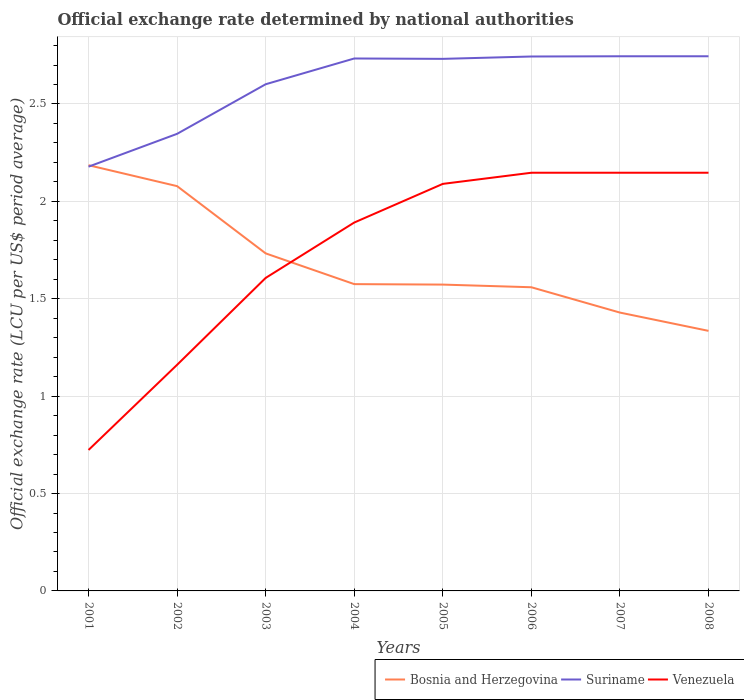Is the number of lines equal to the number of legend labels?
Ensure brevity in your answer.  Yes. Across all years, what is the maximum official exchange rate in Suriname?
Provide a short and direct response. 2.18. In which year was the official exchange rate in Venezuela maximum?
Offer a very short reply. 2001. What is the total official exchange rate in Venezuela in the graph?
Provide a short and direct response. -0.54. What is the difference between the highest and the second highest official exchange rate in Suriname?
Keep it short and to the point. 0.57. What is the difference between the highest and the lowest official exchange rate in Suriname?
Make the answer very short. 5. Is the official exchange rate in Suriname strictly greater than the official exchange rate in Bosnia and Herzegovina over the years?
Your answer should be very brief. No. Are the values on the major ticks of Y-axis written in scientific E-notation?
Ensure brevity in your answer.  No. Does the graph contain any zero values?
Offer a very short reply. No. Where does the legend appear in the graph?
Offer a very short reply. Bottom right. How many legend labels are there?
Give a very brief answer. 3. What is the title of the graph?
Give a very brief answer. Official exchange rate determined by national authorities. Does "Australia" appear as one of the legend labels in the graph?
Your answer should be compact. No. What is the label or title of the X-axis?
Your response must be concise. Years. What is the label or title of the Y-axis?
Keep it short and to the point. Official exchange rate (LCU per US$ period average). What is the Official exchange rate (LCU per US$ period average) in Bosnia and Herzegovina in 2001?
Provide a short and direct response. 2.19. What is the Official exchange rate (LCU per US$ period average) of Suriname in 2001?
Make the answer very short. 2.18. What is the Official exchange rate (LCU per US$ period average) in Venezuela in 2001?
Ensure brevity in your answer.  0.72. What is the Official exchange rate (LCU per US$ period average) of Bosnia and Herzegovina in 2002?
Give a very brief answer. 2.08. What is the Official exchange rate (LCU per US$ period average) of Suriname in 2002?
Your response must be concise. 2.35. What is the Official exchange rate (LCU per US$ period average) of Venezuela in 2002?
Give a very brief answer. 1.16. What is the Official exchange rate (LCU per US$ period average) of Bosnia and Herzegovina in 2003?
Provide a short and direct response. 1.73. What is the Official exchange rate (LCU per US$ period average) of Suriname in 2003?
Provide a succinct answer. 2.6. What is the Official exchange rate (LCU per US$ period average) of Venezuela in 2003?
Your answer should be very brief. 1.61. What is the Official exchange rate (LCU per US$ period average) of Bosnia and Herzegovina in 2004?
Your answer should be very brief. 1.58. What is the Official exchange rate (LCU per US$ period average) of Suriname in 2004?
Ensure brevity in your answer.  2.73. What is the Official exchange rate (LCU per US$ period average) in Venezuela in 2004?
Offer a terse response. 1.89. What is the Official exchange rate (LCU per US$ period average) in Bosnia and Herzegovina in 2005?
Make the answer very short. 1.57. What is the Official exchange rate (LCU per US$ period average) in Suriname in 2005?
Give a very brief answer. 2.73. What is the Official exchange rate (LCU per US$ period average) in Venezuela in 2005?
Make the answer very short. 2.09. What is the Official exchange rate (LCU per US$ period average) in Bosnia and Herzegovina in 2006?
Make the answer very short. 1.56. What is the Official exchange rate (LCU per US$ period average) of Suriname in 2006?
Keep it short and to the point. 2.74. What is the Official exchange rate (LCU per US$ period average) in Venezuela in 2006?
Give a very brief answer. 2.15. What is the Official exchange rate (LCU per US$ period average) in Bosnia and Herzegovina in 2007?
Offer a terse response. 1.43. What is the Official exchange rate (LCU per US$ period average) in Suriname in 2007?
Ensure brevity in your answer.  2.75. What is the Official exchange rate (LCU per US$ period average) of Venezuela in 2007?
Provide a short and direct response. 2.15. What is the Official exchange rate (LCU per US$ period average) of Bosnia and Herzegovina in 2008?
Provide a short and direct response. 1.34. What is the Official exchange rate (LCU per US$ period average) in Suriname in 2008?
Ensure brevity in your answer.  2.75. What is the Official exchange rate (LCU per US$ period average) in Venezuela in 2008?
Offer a very short reply. 2.15. Across all years, what is the maximum Official exchange rate (LCU per US$ period average) of Bosnia and Herzegovina?
Offer a very short reply. 2.19. Across all years, what is the maximum Official exchange rate (LCU per US$ period average) in Suriname?
Give a very brief answer. 2.75. Across all years, what is the maximum Official exchange rate (LCU per US$ period average) in Venezuela?
Offer a very short reply. 2.15. Across all years, what is the minimum Official exchange rate (LCU per US$ period average) of Bosnia and Herzegovina?
Your answer should be compact. 1.34. Across all years, what is the minimum Official exchange rate (LCU per US$ period average) of Suriname?
Provide a succinct answer. 2.18. Across all years, what is the minimum Official exchange rate (LCU per US$ period average) in Venezuela?
Give a very brief answer. 0.72. What is the total Official exchange rate (LCU per US$ period average) in Bosnia and Herzegovina in the graph?
Your response must be concise. 13.47. What is the total Official exchange rate (LCU per US$ period average) of Suriname in the graph?
Ensure brevity in your answer.  20.83. What is the total Official exchange rate (LCU per US$ period average) of Venezuela in the graph?
Make the answer very short. 13.91. What is the difference between the Official exchange rate (LCU per US$ period average) in Bosnia and Herzegovina in 2001 and that in 2002?
Offer a very short reply. 0.11. What is the difference between the Official exchange rate (LCU per US$ period average) in Suriname in 2001 and that in 2002?
Give a very brief answer. -0.17. What is the difference between the Official exchange rate (LCU per US$ period average) of Venezuela in 2001 and that in 2002?
Offer a terse response. -0.44. What is the difference between the Official exchange rate (LCU per US$ period average) of Bosnia and Herzegovina in 2001 and that in 2003?
Your answer should be compact. 0.45. What is the difference between the Official exchange rate (LCU per US$ period average) in Suriname in 2001 and that in 2003?
Give a very brief answer. -0.42. What is the difference between the Official exchange rate (LCU per US$ period average) of Venezuela in 2001 and that in 2003?
Offer a very short reply. -0.88. What is the difference between the Official exchange rate (LCU per US$ period average) of Bosnia and Herzegovina in 2001 and that in 2004?
Your answer should be very brief. 0.61. What is the difference between the Official exchange rate (LCU per US$ period average) of Suriname in 2001 and that in 2004?
Offer a very short reply. -0.56. What is the difference between the Official exchange rate (LCU per US$ period average) of Venezuela in 2001 and that in 2004?
Keep it short and to the point. -1.17. What is the difference between the Official exchange rate (LCU per US$ period average) of Bosnia and Herzegovina in 2001 and that in 2005?
Give a very brief answer. 0.61. What is the difference between the Official exchange rate (LCU per US$ period average) of Suriname in 2001 and that in 2005?
Give a very brief answer. -0.55. What is the difference between the Official exchange rate (LCU per US$ period average) of Venezuela in 2001 and that in 2005?
Keep it short and to the point. -1.37. What is the difference between the Official exchange rate (LCU per US$ period average) of Bosnia and Herzegovina in 2001 and that in 2006?
Give a very brief answer. 0.63. What is the difference between the Official exchange rate (LCU per US$ period average) of Suriname in 2001 and that in 2006?
Keep it short and to the point. -0.57. What is the difference between the Official exchange rate (LCU per US$ period average) in Venezuela in 2001 and that in 2006?
Provide a short and direct response. -1.42. What is the difference between the Official exchange rate (LCU per US$ period average) in Bosnia and Herzegovina in 2001 and that in 2007?
Make the answer very short. 0.76. What is the difference between the Official exchange rate (LCU per US$ period average) in Suriname in 2001 and that in 2007?
Give a very brief answer. -0.57. What is the difference between the Official exchange rate (LCU per US$ period average) of Venezuela in 2001 and that in 2007?
Offer a very short reply. -1.42. What is the difference between the Official exchange rate (LCU per US$ period average) in Bosnia and Herzegovina in 2001 and that in 2008?
Provide a succinct answer. 0.85. What is the difference between the Official exchange rate (LCU per US$ period average) of Suriname in 2001 and that in 2008?
Offer a terse response. -0.57. What is the difference between the Official exchange rate (LCU per US$ period average) of Venezuela in 2001 and that in 2008?
Your response must be concise. -1.42. What is the difference between the Official exchange rate (LCU per US$ period average) of Bosnia and Herzegovina in 2002 and that in 2003?
Your response must be concise. 0.35. What is the difference between the Official exchange rate (LCU per US$ period average) of Suriname in 2002 and that in 2003?
Your answer should be compact. -0.25. What is the difference between the Official exchange rate (LCU per US$ period average) in Venezuela in 2002 and that in 2003?
Keep it short and to the point. -0.45. What is the difference between the Official exchange rate (LCU per US$ period average) of Bosnia and Herzegovina in 2002 and that in 2004?
Provide a short and direct response. 0.5. What is the difference between the Official exchange rate (LCU per US$ period average) in Suriname in 2002 and that in 2004?
Provide a short and direct response. -0.39. What is the difference between the Official exchange rate (LCU per US$ period average) in Venezuela in 2002 and that in 2004?
Your response must be concise. -0.73. What is the difference between the Official exchange rate (LCU per US$ period average) of Bosnia and Herzegovina in 2002 and that in 2005?
Keep it short and to the point. 0.51. What is the difference between the Official exchange rate (LCU per US$ period average) of Suriname in 2002 and that in 2005?
Your response must be concise. -0.38. What is the difference between the Official exchange rate (LCU per US$ period average) of Venezuela in 2002 and that in 2005?
Offer a terse response. -0.93. What is the difference between the Official exchange rate (LCU per US$ period average) in Bosnia and Herzegovina in 2002 and that in 2006?
Your answer should be compact. 0.52. What is the difference between the Official exchange rate (LCU per US$ period average) of Suriname in 2002 and that in 2006?
Provide a succinct answer. -0.4. What is the difference between the Official exchange rate (LCU per US$ period average) of Venezuela in 2002 and that in 2006?
Give a very brief answer. -0.99. What is the difference between the Official exchange rate (LCU per US$ period average) of Bosnia and Herzegovina in 2002 and that in 2007?
Give a very brief answer. 0.65. What is the difference between the Official exchange rate (LCU per US$ period average) of Suriname in 2002 and that in 2007?
Your answer should be compact. -0.4. What is the difference between the Official exchange rate (LCU per US$ period average) in Venezuela in 2002 and that in 2007?
Your answer should be compact. -0.99. What is the difference between the Official exchange rate (LCU per US$ period average) in Bosnia and Herzegovina in 2002 and that in 2008?
Your response must be concise. 0.74. What is the difference between the Official exchange rate (LCU per US$ period average) in Suriname in 2002 and that in 2008?
Offer a terse response. -0.4. What is the difference between the Official exchange rate (LCU per US$ period average) in Venezuela in 2002 and that in 2008?
Provide a short and direct response. -0.99. What is the difference between the Official exchange rate (LCU per US$ period average) of Bosnia and Herzegovina in 2003 and that in 2004?
Make the answer very short. 0.16. What is the difference between the Official exchange rate (LCU per US$ period average) of Suriname in 2003 and that in 2004?
Provide a succinct answer. -0.13. What is the difference between the Official exchange rate (LCU per US$ period average) in Venezuela in 2003 and that in 2004?
Your answer should be very brief. -0.28. What is the difference between the Official exchange rate (LCU per US$ period average) in Bosnia and Herzegovina in 2003 and that in 2005?
Offer a very short reply. 0.16. What is the difference between the Official exchange rate (LCU per US$ period average) of Suriname in 2003 and that in 2005?
Your response must be concise. -0.13. What is the difference between the Official exchange rate (LCU per US$ period average) of Venezuela in 2003 and that in 2005?
Offer a terse response. -0.48. What is the difference between the Official exchange rate (LCU per US$ period average) of Bosnia and Herzegovina in 2003 and that in 2006?
Ensure brevity in your answer.  0.17. What is the difference between the Official exchange rate (LCU per US$ period average) of Suriname in 2003 and that in 2006?
Make the answer very short. -0.14. What is the difference between the Official exchange rate (LCU per US$ period average) in Venezuela in 2003 and that in 2006?
Offer a very short reply. -0.54. What is the difference between the Official exchange rate (LCU per US$ period average) of Bosnia and Herzegovina in 2003 and that in 2007?
Your response must be concise. 0.3. What is the difference between the Official exchange rate (LCU per US$ period average) of Suriname in 2003 and that in 2007?
Your response must be concise. -0.14. What is the difference between the Official exchange rate (LCU per US$ period average) of Venezuela in 2003 and that in 2007?
Provide a short and direct response. -0.54. What is the difference between the Official exchange rate (LCU per US$ period average) of Bosnia and Herzegovina in 2003 and that in 2008?
Keep it short and to the point. 0.4. What is the difference between the Official exchange rate (LCU per US$ period average) in Suriname in 2003 and that in 2008?
Ensure brevity in your answer.  -0.14. What is the difference between the Official exchange rate (LCU per US$ period average) in Venezuela in 2003 and that in 2008?
Your answer should be very brief. -0.54. What is the difference between the Official exchange rate (LCU per US$ period average) in Bosnia and Herzegovina in 2004 and that in 2005?
Make the answer very short. 0. What is the difference between the Official exchange rate (LCU per US$ period average) in Suriname in 2004 and that in 2005?
Keep it short and to the point. 0. What is the difference between the Official exchange rate (LCU per US$ period average) of Venezuela in 2004 and that in 2005?
Provide a succinct answer. -0.2. What is the difference between the Official exchange rate (LCU per US$ period average) in Bosnia and Herzegovina in 2004 and that in 2006?
Make the answer very short. 0.02. What is the difference between the Official exchange rate (LCU per US$ period average) of Suriname in 2004 and that in 2006?
Provide a short and direct response. -0.01. What is the difference between the Official exchange rate (LCU per US$ period average) in Venezuela in 2004 and that in 2006?
Your answer should be compact. -0.26. What is the difference between the Official exchange rate (LCU per US$ period average) of Bosnia and Herzegovina in 2004 and that in 2007?
Offer a very short reply. 0.15. What is the difference between the Official exchange rate (LCU per US$ period average) in Suriname in 2004 and that in 2007?
Make the answer very short. -0.01. What is the difference between the Official exchange rate (LCU per US$ period average) in Venezuela in 2004 and that in 2007?
Offer a terse response. -0.26. What is the difference between the Official exchange rate (LCU per US$ period average) in Bosnia and Herzegovina in 2004 and that in 2008?
Give a very brief answer. 0.24. What is the difference between the Official exchange rate (LCU per US$ period average) of Suriname in 2004 and that in 2008?
Offer a very short reply. -0.01. What is the difference between the Official exchange rate (LCU per US$ period average) of Venezuela in 2004 and that in 2008?
Offer a very short reply. -0.26. What is the difference between the Official exchange rate (LCU per US$ period average) of Bosnia and Herzegovina in 2005 and that in 2006?
Offer a very short reply. 0.01. What is the difference between the Official exchange rate (LCU per US$ period average) of Suriname in 2005 and that in 2006?
Offer a very short reply. -0.01. What is the difference between the Official exchange rate (LCU per US$ period average) in Venezuela in 2005 and that in 2006?
Your answer should be very brief. -0.06. What is the difference between the Official exchange rate (LCU per US$ period average) of Bosnia and Herzegovina in 2005 and that in 2007?
Keep it short and to the point. 0.14. What is the difference between the Official exchange rate (LCU per US$ period average) in Suriname in 2005 and that in 2007?
Ensure brevity in your answer.  -0.01. What is the difference between the Official exchange rate (LCU per US$ period average) of Venezuela in 2005 and that in 2007?
Ensure brevity in your answer.  -0.06. What is the difference between the Official exchange rate (LCU per US$ period average) of Bosnia and Herzegovina in 2005 and that in 2008?
Your answer should be very brief. 0.24. What is the difference between the Official exchange rate (LCU per US$ period average) of Suriname in 2005 and that in 2008?
Ensure brevity in your answer.  -0.01. What is the difference between the Official exchange rate (LCU per US$ period average) of Venezuela in 2005 and that in 2008?
Your answer should be compact. -0.06. What is the difference between the Official exchange rate (LCU per US$ period average) in Bosnia and Herzegovina in 2006 and that in 2007?
Provide a short and direct response. 0.13. What is the difference between the Official exchange rate (LCU per US$ period average) in Suriname in 2006 and that in 2007?
Provide a succinct answer. -0. What is the difference between the Official exchange rate (LCU per US$ period average) of Venezuela in 2006 and that in 2007?
Your response must be concise. 0. What is the difference between the Official exchange rate (LCU per US$ period average) of Bosnia and Herzegovina in 2006 and that in 2008?
Ensure brevity in your answer.  0.22. What is the difference between the Official exchange rate (LCU per US$ period average) in Suriname in 2006 and that in 2008?
Give a very brief answer. -0. What is the difference between the Official exchange rate (LCU per US$ period average) in Venezuela in 2006 and that in 2008?
Your answer should be very brief. 0. What is the difference between the Official exchange rate (LCU per US$ period average) in Bosnia and Herzegovina in 2007 and that in 2008?
Provide a short and direct response. 0.09. What is the difference between the Official exchange rate (LCU per US$ period average) of Venezuela in 2007 and that in 2008?
Ensure brevity in your answer.  0. What is the difference between the Official exchange rate (LCU per US$ period average) of Bosnia and Herzegovina in 2001 and the Official exchange rate (LCU per US$ period average) of Suriname in 2002?
Offer a very short reply. -0.16. What is the difference between the Official exchange rate (LCU per US$ period average) of Bosnia and Herzegovina in 2001 and the Official exchange rate (LCU per US$ period average) of Venezuela in 2002?
Your answer should be compact. 1.02. What is the difference between the Official exchange rate (LCU per US$ period average) of Suriname in 2001 and the Official exchange rate (LCU per US$ period average) of Venezuela in 2002?
Ensure brevity in your answer.  1.02. What is the difference between the Official exchange rate (LCU per US$ period average) in Bosnia and Herzegovina in 2001 and the Official exchange rate (LCU per US$ period average) in Suriname in 2003?
Ensure brevity in your answer.  -0.42. What is the difference between the Official exchange rate (LCU per US$ period average) of Bosnia and Herzegovina in 2001 and the Official exchange rate (LCU per US$ period average) of Venezuela in 2003?
Your answer should be very brief. 0.58. What is the difference between the Official exchange rate (LCU per US$ period average) of Suriname in 2001 and the Official exchange rate (LCU per US$ period average) of Venezuela in 2003?
Ensure brevity in your answer.  0.57. What is the difference between the Official exchange rate (LCU per US$ period average) in Bosnia and Herzegovina in 2001 and the Official exchange rate (LCU per US$ period average) in Suriname in 2004?
Ensure brevity in your answer.  -0.55. What is the difference between the Official exchange rate (LCU per US$ period average) of Bosnia and Herzegovina in 2001 and the Official exchange rate (LCU per US$ period average) of Venezuela in 2004?
Offer a very short reply. 0.29. What is the difference between the Official exchange rate (LCU per US$ period average) of Suriname in 2001 and the Official exchange rate (LCU per US$ period average) of Venezuela in 2004?
Make the answer very short. 0.29. What is the difference between the Official exchange rate (LCU per US$ period average) of Bosnia and Herzegovina in 2001 and the Official exchange rate (LCU per US$ period average) of Suriname in 2005?
Your response must be concise. -0.55. What is the difference between the Official exchange rate (LCU per US$ period average) in Bosnia and Herzegovina in 2001 and the Official exchange rate (LCU per US$ period average) in Venezuela in 2005?
Your response must be concise. 0.1. What is the difference between the Official exchange rate (LCU per US$ period average) of Suriname in 2001 and the Official exchange rate (LCU per US$ period average) of Venezuela in 2005?
Your answer should be very brief. 0.09. What is the difference between the Official exchange rate (LCU per US$ period average) in Bosnia and Herzegovina in 2001 and the Official exchange rate (LCU per US$ period average) in Suriname in 2006?
Your response must be concise. -0.56. What is the difference between the Official exchange rate (LCU per US$ period average) of Bosnia and Herzegovina in 2001 and the Official exchange rate (LCU per US$ period average) of Venezuela in 2006?
Provide a short and direct response. 0.04. What is the difference between the Official exchange rate (LCU per US$ period average) in Suriname in 2001 and the Official exchange rate (LCU per US$ period average) in Venezuela in 2006?
Ensure brevity in your answer.  0.03. What is the difference between the Official exchange rate (LCU per US$ period average) of Bosnia and Herzegovina in 2001 and the Official exchange rate (LCU per US$ period average) of Suriname in 2007?
Give a very brief answer. -0.56. What is the difference between the Official exchange rate (LCU per US$ period average) in Bosnia and Herzegovina in 2001 and the Official exchange rate (LCU per US$ period average) in Venezuela in 2007?
Offer a very short reply. 0.04. What is the difference between the Official exchange rate (LCU per US$ period average) in Suriname in 2001 and the Official exchange rate (LCU per US$ period average) in Venezuela in 2007?
Ensure brevity in your answer.  0.03. What is the difference between the Official exchange rate (LCU per US$ period average) in Bosnia and Herzegovina in 2001 and the Official exchange rate (LCU per US$ period average) in Suriname in 2008?
Keep it short and to the point. -0.56. What is the difference between the Official exchange rate (LCU per US$ period average) of Bosnia and Herzegovina in 2001 and the Official exchange rate (LCU per US$ period average) of Venezuela in 2008?
Your response must be concise. 0.04. What is the difference between the Official exchange rate (LCU per US$ period average) in Suriname in 2001 and the Official exchange rate (LCU per US$ period average) in Venezuela in 2008?
Ensure brevity in your answer.  0.03. What is the difference between the Official exchange rate (LCU per US$ period average) in Bosnia and Herzegovina in 2002 and the Official exchange rate (LCU per US$ period average) in Suriname in 2003?
Provide a succinct answer. -0.52. What is the difference between the Official exchange rate (LCU per US$ period average) in Bosnia and Herzegovina in 2002 and the Official exchange rate (LCU per US$ period average) in Venezuela in 2003?
Ensure brevity in your answer.  0.47. What is the difference between the Official exchange rate (LCU per US$ period average) in Suriname in 2002 and the Official exchange rate (LCU per US$ period average) in Venezuela in 2003?
Provide a short and direct response. 0.74. What is the difference between the Official exchange rate (LCU per US$ period average) in Bosnia and Herzegovina in 2002 and the Official exchange rate (LCU per US$ period average) in Suriname in 2004?
Your answer should be very brief. -0.66. What is the difference between the Official exchange rate (LCU per US$ period average) of Bosnia and Herzegovina in 2002 and the Official exchange rate (LCU per US$ period average) of Venezuela in 2004?
Provide a succinct answer. 0.19. What is the difference between the Official exchange rate (LCU per US$ period average) in Suriname in 2002 and the Official exchange rate (LCU per US$ period average) in Venezuela in 2004?
Offer a very short reply. 0.46. What is the difference between the Official exchange rate (LCU per US$ period average) of Bosnia and Herzegovina in 2002 and the Official exchange rate (LCU per US$ period average) of Suriname in 2005?
Your response must be concise. -0.65. What is the difference between the Official exchange rate (LCU per US$ period average) of Bosnia and Herzegovina in 2002 and the Official exchange rate (LCU per US$ period average) of Venezuela in 2005?
Your answer should be very brief. -0.01. What is the difference between the Official exchange rate (LCU per US$ period average) of Suriname in 2002 and the Official exchange rate (LCU per US$ period average) of Venezuela in 2005?
Your answer should be very brief. 0.26. What is the difference between the Official exchange rate (LCU per US$ period average) in Bosnia and Herzegovina in 2002 and the Official exchange rate (LCU per US$ period average) in Suriname in 2006?
Give a very brief answer. -0.67. What is the difference between the Official exchange rate (LCU per US$ period average) in Bosnia and Herzegovina in 2002 and the Official exchange rate (LCU per US$ period average) in Venezuela in 2006?
Your response must be concise. -0.07. What is the difference between the Official exchange rate (LCU per US$ period average) in Suriname in 2002 and the Official exchange rate (LCU per US$ period average) in Venezuela in 2006?
Your answer should be very brief. 0.2. What is the difference between the Official exchange rate (LCU per US$ period average) in Bosnia and Herzegovina in 2002 and the Official exchange rate (LCU per US$ period average) in Suriname in 2007?
Offer a terse response. -0.67. What is the difference between the Official exchange rate (LCU per US$ period average) of Bosnia and Herzegovina in 2002 and the Official exchange rate (LCU per US$ period average) of Venezuela in 2007?
Give a very brief answer. -0.07. What is the difference between the Official exchange rate (LCU per US$ period average) of Suriname in 2002 and the Official exchange rate (LCU per US$ period average) of Venezuela in 2007?
Give a very brief answer. 0.2. What is the difference between the Official exchange rate (LCU per US$ period average) of Bosnia and Herzegovina in 2002 and the Official exchange rate (LCU per US$ period average) of Suriname in 2008?
Ensure brevity in your answer.  -0.67. What is the difference between the Official exchange rate (LCU per US$ period average) in Bosnia and Herzegovina in 2002 and the Official exchange rate (LCU per US$ period average) in Venezuela in 2008?
Offer a very short reply. -0.07. What is the difference between the Official exchange rate (LCU per US$ period average) of Suriname in 2002 and the Official exchange rate (LCU per US$ period average) of Venezuela in 2008?
Ensure brevity in your answer.  0.2. What is the difference between the Official exchange rate (LCU per US$ period average) of Bosnia and Herzegovina in 2003 and the Official exchange rate (LCU per US$ period average) of Suriname in 2004?
Provide a succinct answer. -1. What is the difference between the Official exchange rate (LCU per US$ period average) in Bosnia and Herzegovina in 2003 and the Official exchange rate (LCU per US$ period average) in Venezuela in 2004?
Your response must be concise. -0.16. What is the difference between the Official exchange rate (LCU per US$ period average) in Suriname in 2003 and the Official exchange rate (LCU per US$ period average) in Venezuela in 2004?
Offer a terse response. 0.71. What is the difference between the Official exchange rate (LCU per US$ period average) in Bosnia and Herzegovina in 2003 and the Official exchange rate (LCU per US$ period average) in Suriname in 2005?
Provide a short and direct response. -1. What is the difference between the Official exchange rate (LCU per US$ period average) of Bosnia and Herzegovina in 2003 and the Official exchange rate (LCU per US$ period average) of Venezuela in 2005?
Give a very brief answer. -0.36. What is the difference between the Official exchange rate (LCU per US$ period average) in Suriname in 2003 and the Official exchange rate (LCU per US$ period average) in Venezuela in 2005?
Provide a succinct answer. 0.51. What is the difference between the Official exchange rate (LCU per US$ period average) of Bosnia and Herzegovina in 2003 and the Official exchange rate (LCU per US$ period average) of Suriname in 2006?
Make the answer very short. -1.01. What is the difference between the Official exchange rate (LCU per US$ period average) in Bosnia and Herzegovina in 2003 and the Official exchange rate (LCU per US$ period average) in Venezuela in 2006?
Offer a terse response. -0.41. What is the difference between the Official exchange rate (LCU per US$ period average) in Suriname in 2003 and the Official exchange rate (LCU per US$ period average) in Venezuela in 2006?
Keep it short and to the point. 0.45. What is the difference between the Official exchange rate (LCU per US$ period average) in Bosnia and Herzegovina in 2003 and the Official exchange rate (LCU per US$ period average) in Suriname in 2007?
Your response must be concise. -1.01. What is the difference between the Official exchange rate (LCU per US$ period average) of Bosnia and Herzegovina in 2003 and the Official exchange rate (LCU per US$ period average) of Venezuela in 2007?
Provide a succinct answer. -0.41. What is the difference between the Official exchange rate (LCU per US$ period average) in Suriname in 2003 and the Official exchange rate (LCU per US$ period average) in Venezuela in 2007?
Give a very brief answer. 0.45. What is the difference between the Official exchange rate (LCU per US$ period average) of Bosnia and Herzegovina in 2003 and the Official exchange rate (LCU per US$ period average) of Suriname in 2008?
Make the answer very short. -1.01. What is the difference between the Official exchange rate (LCU per US$ period average) of Bosnia and Herzegovina in 2003 and the Official exchange rate (LCU per US$ period average) of Venezuela in 2008?
Provide a succinct answer. -0.41. What is the difference between the Official exchange rate (LCU per US$ period average) of Suriname in 2003 and the Official exchange rate (LCU per US$ period average) of Venezuela in 2008?
Give a very brief answer. 0.45. What is the difference between the Official exchange rate (LCU per US$ period average) in Bosnia and Herzegovina in 2004 and the Official exchange rate (LCU per US$ period average) in Suriname in 2005?
Give a very brief answer. -1.16. What is the difference between the Official exchange rate (LCU per US$ period average) in Bosnia and Herzegovina in 2004 and the Official exchange rate (LCU per US$ period average) in Venezuela in 2005?
Your answer should be compact. -0.51. What is the difference between the Official exchange rate (LCU per US$ period average) of Suriname in 2004 and the Official exchange rate (LCU per US$ period average) of Venezuela in 2005?
Keep it short and to the point. 0.64. What is the difference between the Official exchange rate (LCU per US$ period average) in Bosnia and Herzegovina in 2004 and the Official exchange rate (LCU per US$ period average) in Suriname in 2006?
Your answer should be very brief. -1.17. What is the difference between the Official exchange rate (LCU per US$ period average) in Bosnia and Herzegovina in 2004 and the Official exchange rate (LCU per US$ period average) in Venezuela in 2006?
Offer a terse response. -0.57. What is the difference between the Official exchange rate (LCU per US$ period average) in Suriname in 2004 and the Official exchange rate (LCU per US$ period average) in Venezuela in 2006?
Make the answer very short. 0.59. What is the difference between the Official exchange rate (LCU per US$ period average) of Bosnia and Herzegovina in 2004 and the Official exchange rate (LCU per US$ period average) of Suriname in 2007?
Your answer should be very brief. -1.17. What is the difference between the Official exchange rate (LCU per US$ period average) in Bosnia and Herzegovina in 2004 and the Official exchange rate (LCU per US$ period average) in Venezuela in 2007?
Keep it short and to the point. -0.57. What is the difference between the Official exchange rate (LCU per US$ period average) in Suriname in 2004 and the Official exchange rate (LCU per US$ period average) in Venezuela in 2007?
Your answer should be compact. 0.59. What is the difference between the Official exchange rate (LCU per US$ period average) of Bosnia and Herzegovina in 2004 and the Official exchange rate (LCU per US$ period average) of Suriname in 2008?
Provide a short and direct response. -1.17. What is the difference between the Official exchange rate (LCU per US$ period average) in Bosnia and Herzegovina in 2004 and the Official exchange rate (LCU per US$ period average) in Venezuela in 2008?
Your answer should be very brief. -0.57. What is the difference between the Official exchange rate (LCU per US$ period average) in Suriname in 2004 and the Official exchange rate (LCU per US$ period average) in Venezuela in 2008?
Give a very brief answer. 0.59. What is the difference between the Official exchange rate (LCU per US$ period average) of Bosnia and Herzegovina in 2005 and the Official exchange rate (LCU per US$ period average) of Suriname in 2006?
Provide a succinct answer. -1.17. What is the difference between the Official exchange rate (LCU per US$ period average) in Bosnia and Herzegovina in 2005 and the Official exchange rate (LCU per US$ period average) in Venezuela in 2006?
Offer a very short reply. -0.57. What is the difference between the Official exchange rate (LCU per US$ period average) in Suriname in 2005 and the Official exchange rate (LCU per US$ period average) in Venezuela in 2006?
Provide a short and direct response. 0.58. What is the difference between the Official exchange rate (LCU per US$ period average) in Bosnia and Herzegovina in 2005 and the Official exchange rate (LCU per US$ period average) in Suriname in 2007?
Offer a very short reply. -1.17. What is the difference between the Official exchange rate (LCU per US$ period average) of Bosnia and Herzegovina in 2005 and the Official exchange rate (LCU per US$ period average) of Venezuela in 2007?
Give a very brief answer. -0.57. What is the difference between the Official exchange rate (LCU per US$ period average) in Suriname in 2005 and the Official exchange rate (LCU per US$ period average) in Venezuela in 2007?
Offer a terse response. 0.58. What is the difference between the Official exchange rate (LCU per US$ period average) in Bosnia and Herzegovina in 2005 and the Official exchange rate (LCU per US$ period average) in Suriname in 2008?
Keep it short and to the point. -1.17. What is the difference between the Official exchange rate (LCU per US$ period average) in Bosnia and Herzegovina in 2005 and the Official exchange rate (LCU per US$ period average) in Venezuela in 2008?
Your response must be concise. -0.57. What is the difference between the Official exchange rate (LCU per US$ period average) in Suriname in 2005 and the Official exchange rate (LCU per US$ period average) in Venezuela in 2008?
Provide a short and direct response. 0.58. What is the difference between the Official exchange rate (LCU per US$ period average) in Bosnia and Herzegovina in 2006 and the Official exchange rate (LCU per US$ period average) in Suriname in 2007?
Your response must be concise. -1.19. What is the difference between the Official exchange rate (LCU per US$ period average) of Bosnia and Herzegovina in 2006 and the Official exchange rate (LCU per US$ period average) of Venezuela in 2007?
Provide a succinct answer. -0.59. What is the difference between the Official exchange rate (LCU per US$ period average) of Suriname in 2006 and the Official exchange rate (LCU per US$ period average) of Venezuela in 2007?
Make the answer very short. 0.6. What is the difference between the Official exchange rate (LCU per US$ period average) of Bosnia and Herzegovina in 2006 and the Official exchange rate (LCU per US$ period average) of Suriname in 2008?
Your answer should be very brief. -1.19. What is the difference between the Official exchange rate (LCU per US$ period average) in Bosnia and Herzegovina in 2006 and the Official exchange rate (LCU per US$ period average) in Venezuela in 2008?
Provide a short and direct response. -0.59. What is the difference between the Official exchange rate (LCU per US$ period average) of Suriname in 2006 and the Official exchange rate (LCU per US$ period average) of Venezuela in 2008?
Your answer should be very brief. 0.6. What is the difference between the Official exchange rate (LCU per US$ period average) in Bosnia and Herzegovina in 2007 and the Official exchange rate (LCU per US$ period average) in Suriname in 2008?
Your answer should be very brief. -1.32. What is the difference between the Official exchange rate (LCU per US$ period average) of Bosnia and Herzegovina in 2007 and the Official exchange rate (LCU per US$ period average) of Venezuela in 2008?
Make the answer very short. -0.72. What is the difference between the Official exchange rate (LCU per US$ period average) in Suriname in 2007 and the Official exchange rate (LCU per US$ period average) in Venezuela in 2008?
Offer a terse response. 0.6. What is the average Official exchange rate (LCU per US$ period average) of Bosnia and Herzegovina per year?
Keep it short and to the point. 1.68. What is the average Official exchange rate (LCU per US$ period average) of Suriname per year?
Offer a very short reply. 2.6. What is the average Official exchange rate (LCU per US$ period average) in Venezuela per year?
Ensure brevity in your answer.  1.74. In the year 2001, what is the difference between the Official exchange rate (LCU per US$ period average) in Bosnia and Herzegovina and Official exchange rate (LCU per US$ period average) in Suriname?
Keep it short and to the point. 0.01. In the year 2001, what is the difference between the Official exchange rate (LCU per US$ period average) in Bosnia and Herzegovina and Official exchange rate (LCU per US$ period average) in Venezuela?
Provide a short and direct response. 1.46. In the year 2001, what is the difference between the Official exchange rate (LCU per US$ period average) of Suriname and Official exchange rate (LCU per US$ period average) of Venezuela?
Ensure brevity in your answer.  1.45. In the year 2002, what is the difference between the Official exchange rate (LCU per US$ period average) of Bosnia and Herzegovina and Official exchange rate (LCU per US$ period average) of Suriname?
Make the answer very short. -0.27. In the year 2002, what is the difference between the Official exchange rate (LCU per US$ period average) of Bosnia and Herzegovina and Official exchange rate (LCU per US$ period average) of Venezuela?
Keep it short and to the point. 0.92. In the year 2002, what is the difference between the Official exchange rate (LCU per US$ period average) of Suriname and Official exchange rate (LCU per US$ period average) of Venezuela?
Your answer should be compact. 1.19. In the year 2003, what is the difference between the Official exchange rate (LCU per US$ period average) of Bosnia and Herzegovina and Official exchange rate (LCU per US$ period average) of Suriname?
Give a very brief answer. -0.87. In the year 2003, what is the difference between the Official exchange rate (LCU per US$ period average) in Bosnia and Herzegovina and Official exchange rate (LCU per US$ period average) in Venezuela?
Offer a very short reply. 0.13. In the year 2003, what is the difference between the Official exchange rate (LCU per US$ period average) in Suriname and Official exchange rate (LCU per US$ period average) in Venezuela?
Make the answer very short. 0.99. In the year 2004, what is the difference between the Official exchange rate (LCU per US$ period average) of Bosnia and Herzegovina and Official exchange rate (LCU per US$ period average) of Suriname?
Give a very brief answer. -1.16. In the year 2004, what is the difference between the Official exchange rate (LCU per US$ period average) of Bosnia and Herzegovina and Official exchange rate (LCU per US$ period average) of Venezuela?
Keep it short and to the point. -0.32. In the year 2004, what is the difference between the Official exchange rate (LCU per US$ period average) of Suriname and Official exchange rate (LCU per US$ period average) of Venezuela?
Make the answer very short. 0.84. In the year 2005, what is the difference between the Official exchange rate (LCU per US$ period average) of Bosnia and Herzegovina and Official exchange rate (LCU per US$ period average) of Suriname?
Ensure brevity in your answer.  -1.16. In the year 2005, what is the difference between the Official exchange rate (LCU per US$ period average) in Bosnia and Herzegovina and Official exchange rate (LCU per US$ period average) in Venezuela?
Give a very brief answer. -0.52. In the year 2005, what is the difference between the Official exchange rate (LCU per US$ period average) of Suriname and Official exchange rate (LCU per US$ period average) of Venezuela?
Provide a short and direct response. 0.64. In the year 2006, what is the difference between the Official exchange rate (LCU per US$ period average) in Bosnia and Herzegovina and Official exchange rate (LCU per US$ period average) in Suriname?
Make the answer very short. -1.18. In the year 2006, what is the difference between the Official exchange rate (LCU per US$ period average) of Bosnia and Herzegovina and Official exchange rate (LCU per US$ period average) of Venezuela?
Your answer should be compact. -0.59. In the year 2006, what is the difference between the Official exchange rate (LCU per US$ period average) of Suriname and Official exchange rate (LCU per US$ period average) of Venezuela?
Provide a succinct answer. 0.6. In the year 2007, what is the difference between the Official exchange rate (LCU per US$ period average) of Bosnia and Herzegovina and Official exchange rate (LCU per US$ period average) of Suriname?
Your response must be concise. -1.32. In the year 2007, what is the difference between the Official exchange rate (LCU per US$ period average) of Bosnia and Herzegovina and Official exchange rate (LCU per US$ period average) of Venezuela?
Your answer should be compact. -0.72. In the year 2007, what is the difference between the Official exchange rate (LCU per US$ period average) of Suriname and Official exchange rate (LCU per US$ period average) of Venezuela?
Your answer should be compact. 0.6. In the year 2008, what is the difference between the Official exchange rate (LCU per US$ period average) of Bosnia and Herzegovina and Official exchange rate (LCU per US$ period average) of Suriname?
Ensure brevity in your answer.  -1.41. In the year 2008, what is the difference between the Official exchange rate (LCU per US$ period average) of Bosnia and Herzegovina and Official exchange rate (LCU per US$ period average) of Venezuela?
Your answer should be very brief. -0.81. In the year 2008, what is the difference between the Official exchange rate (LCU per US$ period average) of Suriname and Official exchange rate (LCU per US$ period average) of Venezuela?
Your response must be concise. 0.6. What is the ratio of the Official exchange rate (LCU per US$ period average) of Bosnia and Herzegovina in 2001 to that in 2002?
Your answer should be compact. 1.05. What is the ratio of the Official exchange rate (LCU per US$ period average) in Suriname in 2001 to that in 2002?
Offer a very short reply. 0.93. What is the ratio of the Official exchange rate (LCU per US$ period average) of Venezuela in 2001 to that in 2002?
Offer a very short reply. 0.62. What is the ratio of the Official exchange rate (LCU per US$ period average) of Bosnia and Herzegovina in 2001 to that in 2003?
Your answer should be very brief. 1.26. What is the ratio of the Official exchange rate (LCU per US$ period average) in Suriname in 2001 to that in 2003?
Provide a succinct answer. 0.84. What is the ratio of the Official exchange rate (LCU per US$ period average) of Venezuela in 2001 to that in 2003?
Your answer should be compact. 0.45. What is the ratio of the Official exchange rate (LCU per US$ period average) in Bosnia and Herzegovina in 2001 to that in 2004?
Offer a very short reply. 1.39. What is the ratio of the Official exchange rate (LCU per US$ period average) in Suriname in 2001 to that in 2004?
Your response must be concise. 0.8. What is the ratio of the Official exchange rate (LCU per US$ period average) in Venezuela in 2001 to that in 2004?
Your answer should be very brief. 0.38. What is the ratio of the Official exchange rate (LCU per US$ period average) of Bosnia and Herzegovina in 2001 to that in 2005?
Your answer should be compact. 1.39. What is the ratio of the Official exchange rate (LCU per US$ period average) of Suriname in 2001 to that in 2005?
Provide a succinct answer. 0.8. What is the ratio of the Official exchange rate (LCU per US$ period average) of Venezuela in 2001 to that in 2005?
Offer a terse response. 0.35. What is the ratio of the Official exchange rate (LCU per US$ period average) in Bosnia and Herzegovina in 2001 to that in 2006?
Your answer should be compact. 1.4. What is the ratio of the Official exchange rate (LCU per US$ period average) of Suriname in 2001 to that in 2006?
Ensure brevity in your answer.  0.79. What is the ratio of the Official exchange rate (LCU per US$ period average) in Venezuela in 2001 to that in 2006?
Provide a short and direct response. 0.34. What is the ratio of the Official exchange rate (LCU per US$ period average) of Bosnia and Herzegovina in 2001 to that in 2007?
Give a very brief answer. 1.53. What is the ratio of the Official exchange rate (LCU per US$ period average) in Suriname in 2001 to that in 2007?
Make the answer very short. 0.79. What is the ratio of the Official exchange rate (LCU per US$ period average) of Venezuela in 2001 to that in 2007?
Provide a short and direct response. 0.34. What is the ratio of the Official exchange rate (LCU per US$ period average) of Bosnia and Herzegovina in 2001 to that in 2008?
Make the answer very short. 1.64. What is the ratio of the Official exchange rate (LCU per US$ period average) in Suriname in 2001 to that in 2008?
Your response must be concise. 0.79. What is the ratio of the Official exchange rate (LCU per US$ period average) of Venezuela in 2001 to that in 2008?
Your answer should be very brief. 0.34. What is the ratio of the Official exchange rate (LCU per US$ period average) of Bosnia and Herzegovina in 2002 to that in 2003?
Offer a very short reply. 1.2. What is the ratio of the Official exchange rate (LCU per US$ period average) in Suriname in 2002 to that in 2003?
Offer a very short reply. 0.9. What is the ratio of the Official exchange rate (LCU per US$ period average) in Venezuela in 2002 to that in 2003?
Offer a terse response. 0.72. What is the ratio of the Official exchange rate (LCU per US$ period average) in Bosnia and Herzegovina in 2002 to that in 2004?
Make the answer very short. 1.32. What is the ratio of the Official exchange rate (LCU per US$ period average) of Suriname in 2002 to that in 2004?
Keep it short and to the point. 0.86. What is the ratio of the Official exchange rate (LCU per US$ period average) in Venezuela in 2002 to that in 2004?
Keep it short and to the point. 0.61. What is the ratio of the Official exchange rate (LCU per US$ period average) in Bosnia and Herzegovina in 2002 to that in 2005?
Offer a terse response. 1.32. What is the ratio of the Official exchange rate (LCU per US$ period average) in Suriname in 2002 to that in 2005?
Your answer should be very brief. 0.86. What is the ratio of the Official exchange rate (LCU per US$ period average) in Venezuela in 2002 to that in 2005?
Offer a terse response. 0.56. What is the ratio of the Official exchange rate (LCU per US$ period average) in Bosnia and Herzegovina in 2002 to that in 2006?
Make the answer very short. 1.33. What is the ratio of the Official exchange rate (LCU per US$ period average) of Suriname in 2002 to that in 2006?
Provide a succinct answer. 0.86. What is the ratio of the Official exchange rate (LCU per US$ period average) in Venezuela in 2002 to that in 2006?
Offer a very short reply. 0.54. What is the ratio of the Official exchange rate (LCU per US$ period average) of Bosnia and Herzegovina in 2002 to that in 2007?
Ensure brevity in your answer.  1.45. What is the ratio of the Official exchange rate (LCU per US$ period average) in Suriname in 2002 to that in 2007?
Ensure brevity in your answer.  0.85. What is the ratio of the Official exchange rate (LCU per US$ period average) of Venezuela in 2002 to that in 2007?
Provide a succinct answer. 0.54. What is the ratio of the Official exchange rate (LCU per US$ period average) in Bosnia and Herzegovina in 2002 to that in 2008?
Keep it short and to the point. 1.56. What is the ratio of the Official exchange rate (LCU per US$ period average) of Suriname in 2002 to that in 2008?
Give a very brief answer. 0.85. What is the ratio of the Official exchange rate (LCU per US$ period average) in Venezuela in 2002 to that in 2008?
Keep it short and to the point. 0.54. What is the ratio of the Official exchange rate (LCU per US$ period average) in Bosnia and Herzegovina in 2003 to that in 2004?
Keep it short and to the point. 1.1. What is the ratio of the Official exchange rate (LCU per US$ period average) of Suriname in 2003 to that in 2004?
Keep it short and to the point. 0.95. What is the ratio of the Official exchange rate (LCU per US$ period average) of Venezuela in 2003 to that in 2004?
Your response must be concise. 0.85. What is the ratio of the Official exchange rate (LCU per US$ period average) in Bosnia and Herzegovina in 2003 to that in 2005?
Ensure brevity in your answer.  1.1. What is the ratio of the Official exchange rate (LCU per US$ period average) of Suriname in 2003 to that in 2005?
Provide a short and direct response. 0.95. What is the ratio of the Official exchange rate (LCU per US$ period average) in Venezuela in 2003 to that in 2005?
Provide a short and direct response. 0.77. What is the ratio of the Official exchange rate (LCU per US$ period average) of Bosnia and Herzegovina in 2003 to that in 2006?
Provide a succinct answer. 1.11. What is the ratio of the Official exchange rate (LCU per US$ period average) of Suriname in 2003 to that in 2006?
Your answer should be very brief. 0.95. What is the ratio of the Official exchange rate (LCU per US$ period average) in Venezuela in 2003 to that in 2006?
Make the answer very short. 0.75. What is the ratio of the Official exchange rate (LCU per US$ period average) of Bosnia and Herzegovina in 2003 to that in 2007?
Provide a succinct answer. 1.21. What is the ratio of the Official exchange rate (LCU per US$ period average) in Suriname in 2003 to that in 2007?
Ensure brevity in your answer.  0.95. What is the ratio of the Official exchange rate (LCU per US$ period average) of Venezuela in 2003 to that in 2007?
Ensure brevity in your answer.  0.75. What is the ratio of the Official exchange rate (LCU per US$ period average) of Bosnia and Herzegovina in 2003 to that in 2008?
Your answer should be very brief. 1.3. What is the ratio of the Official exchange rate (LCU per US$ period average) in Suriname in 2003 to that in 2008?
Provide a short and direct response. 0.95. What is the ratio of the Official exchange rate (LCU per US$ period average) of Venezuela in 2003 to that in 2008?
Ensure brevity in your answer.  0.75. What is the ratio of the Official exchange rate (LCU per US$ period average) of Venezuela in 2004 to that in 2005?
Your answer should be very brief. 0.91. What is the ratio of the Official exchange rate (LCU per US$ period average) of Bosnia and Herzegovina in 2004 to that in 2006?
Your answer should be very brief. 1.01. What is the ratio of the Official exchange rate (LCU per US$ period average) of Venezuela in 2004 to that in 2006?
Your answer should be compact. 0.88. What is the ratio of the Official exchange rate (LCU per US$ period average) of Bosnia and Herzegovina in 2004 to that in 2007?
Offer a very short reply. 1.1. What is the ratio of the Official exchange rate (LCU per US$ period average) in Venezuela in 2004 to that in 2007?
Your answer should be compact. 0.88. What is the ratio of the Official exchange rate (LCU per US$ period average) in Bosnia and Herzegovina in 2004 to that in 2008?
Make the answer very short. 1.18. What is the ratio of the Official exchange rate (LCU per US$ period average) in Venezuela in 2004 to that in 2008?
Give a very brief answer. 0.88. What is the ratio of the Official exchange rate (LCU per US$ period average) in Bosnia and Herzegovina in 2005 to that in 2006?
Provide a succinct answer. 1.01. What is the ratio of the Official exchange rate (LCU per US$ period average) of Suriname in 2005 to that in 2006?
Keep it short and to the point. 1. What is the ratio of the Official exchange rate (LCU per US$ period average) in Venezuela in 2005 to that in 2006?
Your answer should be very brief. 0.97. What is the ratio of the Official exchange rate (LCU per US$ period average) in Bosnia and Herzegovina in 2005 to that in 2007?
Offer a terse response. 1.1. What is the ratio of the Official exchange rate (LCU per US$ period average) of Venezuela in 2005 to that in 2007?
Your answer should be very brief. 0.97. What is the ratio of the Official exchange rate (LCU per US$ period average) in Bosnia and Herzegovina in 2005 to that in 2008?
Make the answer very short. 1.18. What is the ratio of the Official exchange rate (LCU per US$ period average) of Suriname in 2005 to that in 2008?
Offer a terse response. 1. What is the ratio of the Official exchange rate (LCU per US$ period average) of Venezuela in 2005 to that in 2008?
Give a very brief answer. 0.97. What is the ratio of the Official exchange rate (LCU per US$ period average) in Bosnia and Herzegovina in 2006 to that in 2007?
Make the answer very short. 1.09. What is the ratio of the Official exchange rate (LCU per US$ period average) in Suriname in 2006 to that in 2007?
Offer a very short reply. 1. What is the ratio of the Official exchange rate (LCU per US$ period average) in Venezuela in 2006 to that in 2007?
Make the answer very short. 1. What is the ratio of the Official exchange rate (LCU per US$ period average) of Bosnia and Herzegovina in 2006 to that in 2008?
Provide a short and direct response. 1.17. What is the ratio of the Official exchange rate (LCU per US$ period average) in Suriname in 2006 to that in 2008?
Provide a short and direct response. 1. What is the ratio of the Official exchange rate (LCU per US$ period average) of Venezuela in 2006 to that in 2008?
Provide a succinct answer. 1. What is the ratio of the Official exchange rate (LCU per US$ period average) in Bosnia and Herzegovina in 2007 to that in 2008?
Keep it short and to the point. 1.07. What is the ratio of the Official exchange rate (LCU per US$ period average) of Suriname in 2007 to that in 2008?
Make the answer very short. 1. What is the difference between the highest and the second highest Official exchange rate (LCU per US$ period average) of Bosnia and Herzegovina?
Your answer should be very brief. 0.11. What is the difference between the highest and the second highest Official exchange rate (LCU per US$ period average) in Venezuela?
Offer a terse response. 0. What is the difference between the highest and the lowest Official exchange rate (LCU per US$ period average) in Bosnia and Herzegovina?
Offer a very short reply. 0.85. What is the difference between the highest and the lowest Official exchange rate (LCU per US$ period average) of Suriname?
Offer a terse response. 0.57. What is the difference between the highest and the lowest Official exchange rate (LCU per US$ period average) in Venezuela?
Give a very brief answer. 1.42. 